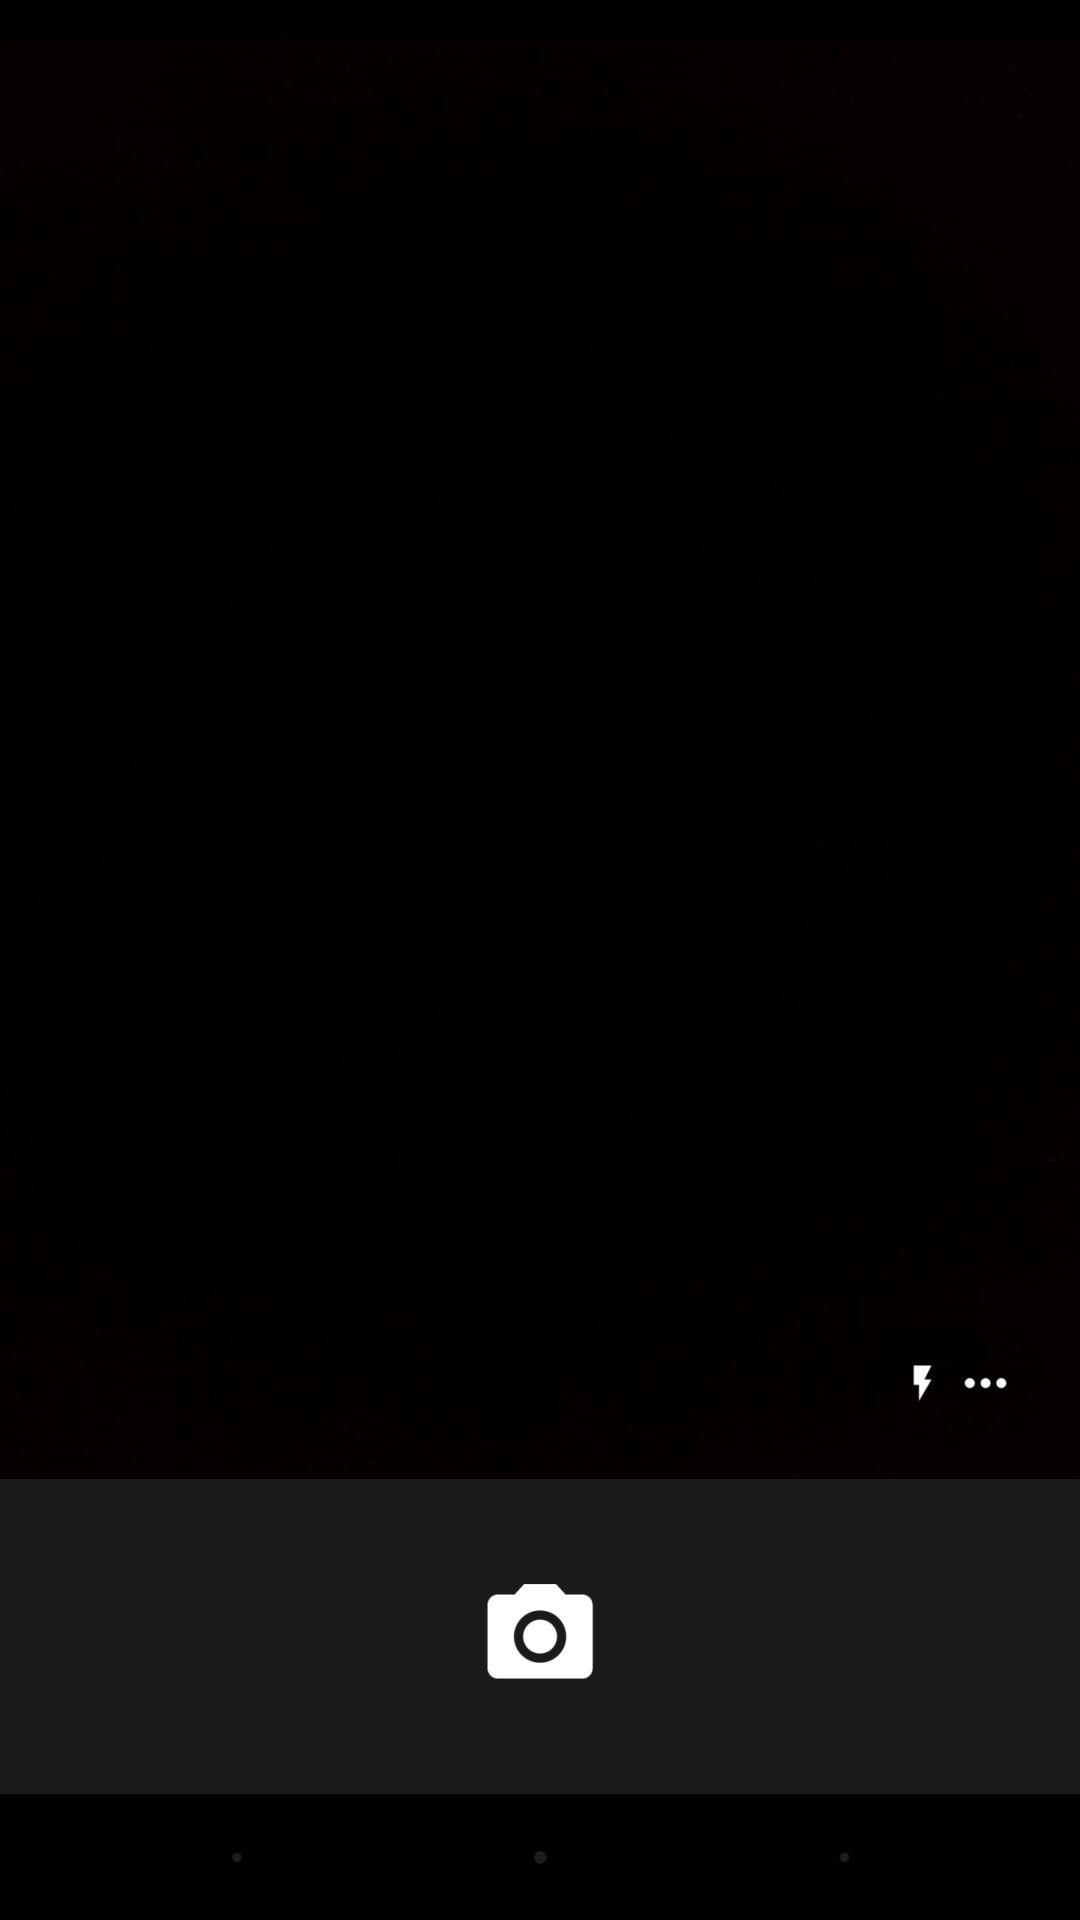How many more dots are there than lightning bolts?
Answer the question using a single word or phrase. 2 